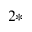<formula> <loc_0><loc_0><loc_500><loc_500>^ { 2 * }</formula> 